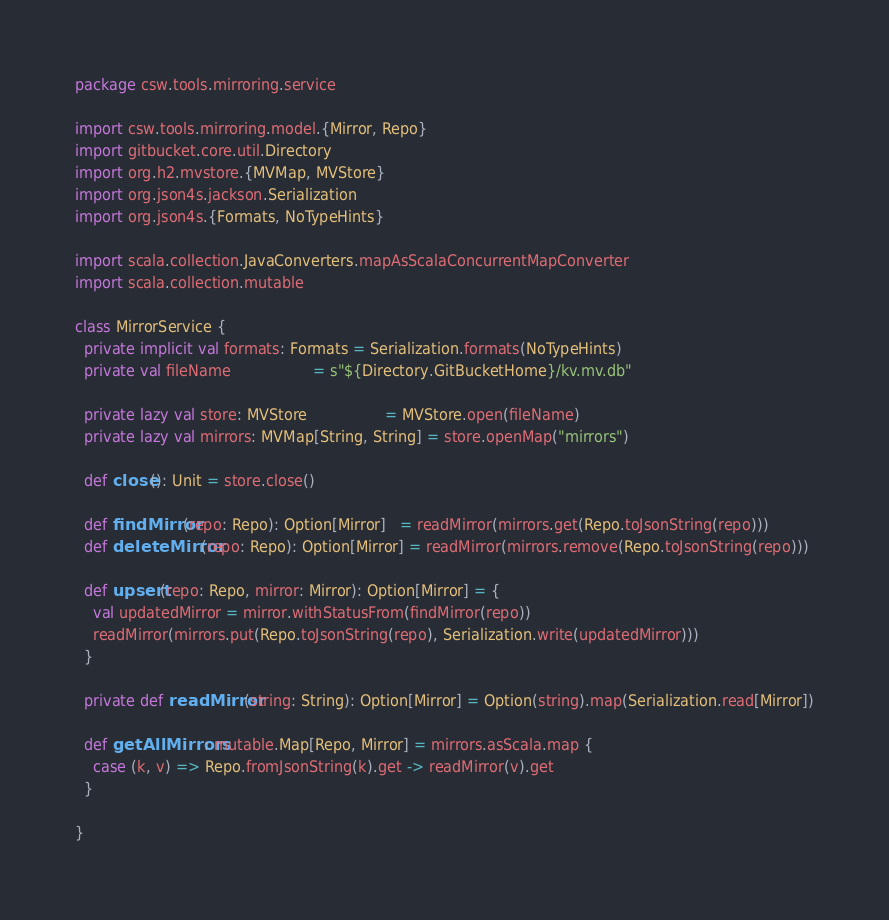<code> <loc_0><loc_0><loc_500><loc_500><_Scala_>package csw.tools.mirroring.service

import csw.tools.mirroring.model.{Mirror, Repo}
import gitbucket.core.util.Directory
import org.h2.mvstore.{MVMap, MVStore}
import org.json4s.jackson.Serialization
import org.json4s.{Formats, NoTypeHints}

import scala.collection.JavaConverters.mapAsScalaConcurrentMapConverter
import scala.collection.mutable

class MirrorService {
  private implicit val formats: Formats = Serialization.formats(NoTypeHints)
  private val fileName                  = s"${Directory.GitBucketHome}/kv.mv.db"

  private lazy val store: MVStore                 = MVStore.open(fileName)
  private lazy val mirrors: MVMap[String, String] = store.openMap("mirrors")

  def close(): Unit = store.close()

  def findMirror(repo: Repo): Option[Mirror]   = readMirror(mirrors.get(Repo.toJsonString(repo)))
  def deleteMirror(repo: Repo): Option[Mirror] = readMirror(mirrors.remove(Repo.toJsonString(repo)))

  def upsert(repo: Repo, mirror: Mirror): Option[Mirror] = {
    val updatedMirror = mirror.withStatusFrom(findMirror(repo))
    readMirror(mirrors.put(Repo.toJsonString(repo), Serialization.write(updatedMirror)))
  }

  private def readMirror(string: String): Option[Mirror] = Option(string).map(Serialization.read[Mirror])

  def getAllMirrors: mutable.Map[Repo, Mirror] = mirrors.asScala.map {
    case (k, v) => Repo.fromJsonString(k).get -> readMirror(v).get
  }

}
</code> 